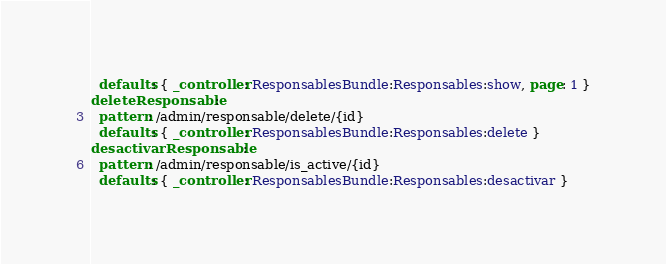<code> <loc_0><loc_0><loc_500><loc_500><_YAML_>  defaults: { _controller: ResponsablesBundle:Responsables:show, page: 1 }
deleteResponsable:
  pattern: /admin/responsable/delete/{id}
  defaults: { _controller: ResponsablesBundle:Responsables:delete }
desactivarResponsable:
  pattern: /admin/responsable/is_active/{id}
  defaults: { _controller: ResponsablesBundle:Responsables:desactivar }
</code> 